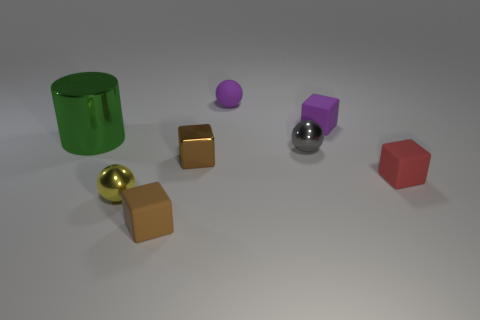Add 1 tiny purple rubber spheres. How many objects exist? 9 Subtract all spheres. How many objects are left? 5 Add 1 brown rubber blocks. How many brown rubber blocks are left? 2 Add 3 cyan cubes. How many cyan cubes exist? 3 Subtract 1 red blocks. How many objects are left? 7 Subtract all tiny things. Subtract all small green matte cylinders. How many objects are left? 1 